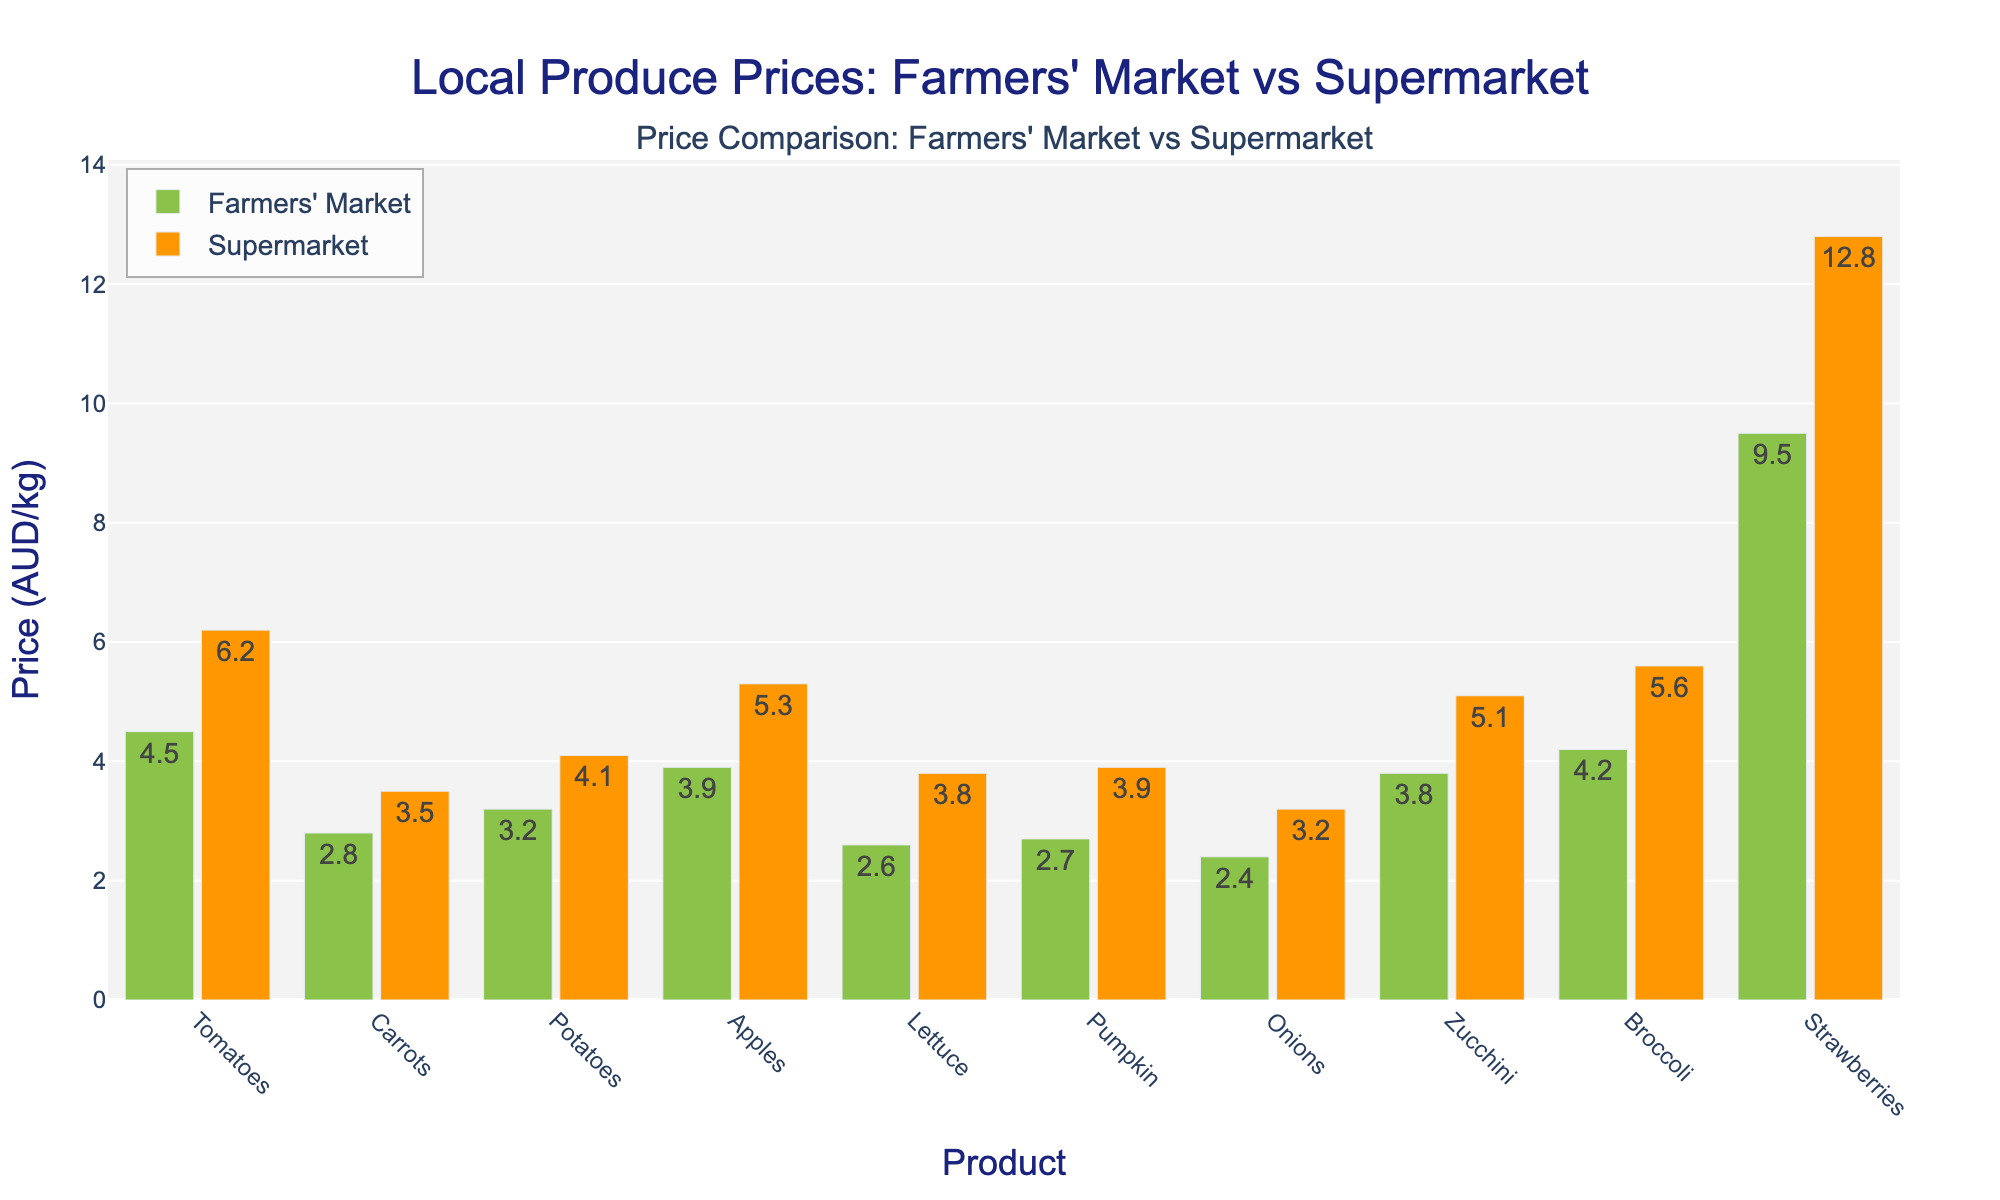Which product shows the largest price difference between the farmers' market and the supermarket? To find the product with the largest price difference, subtract the price of the farmers' market from the supermarket for each product and compare the differences.
Answer: Strawberries Which product is the cheapest at the farmers' market? Identify the lowest bar for farmers' market prices.
Answer: Onions Which product has a smaller price difference between the farmers' market and the supermarket, potatoes or zucchini? Calculate the price differences for each product. Potatoes: 4.10 - 3.20 = 0.90 AUD/kg, Zucchini: 5.10 - 3.80 = 1.30 AUD/kg. Compare the differences.
Answer: Potatoes How much more expensive are the tomatoes at the supermarket compared to the farmers' market? Subtract the price at the farmers' market from the price at the supermarket for tomatoes.
Answer: 1.70 AUD/kg What is the average price of apples at both the farmers' market and the supermarket? Calculate the mean of the two values: (3.90 + 5.30) / 2
Answer: 4.60 AUD/kg Which product has the closest price between the farmers' market and the supermarket? Find the smallest difference between the prices of all products.
Answer: Onions How much would it cost to buy 1 kilogram of each product at the farmers' market? Add up the farmers' market prices for all products: 4.50 + 2.80 + 3.20 + 3.90 + 2.60 + 2.70 + 2.40 + 3.80 + 4.20 + 9.50
Answer: 39.60 AUD Which product shows a greater price increase from the farmers' market to the supermarket, carrots or lettuce? Compare the price increases for carrots: 3.50 - 2.80 = 0.70 AUD/kg and lettuce: 3.80 - 2.60 = 1.20 AUD/kg.
Answer: Lettuce Do most products have higher prices at the supermarket or the farmers' market? Compare the height of bars representing prices for most products.
Answer: Supermarket Which product is more cost-effective to buy from the farmers' market than the supermarket? Identify the products where the farmers' market price is significantly lower than the supermarket price.
Answer: Strawberries 